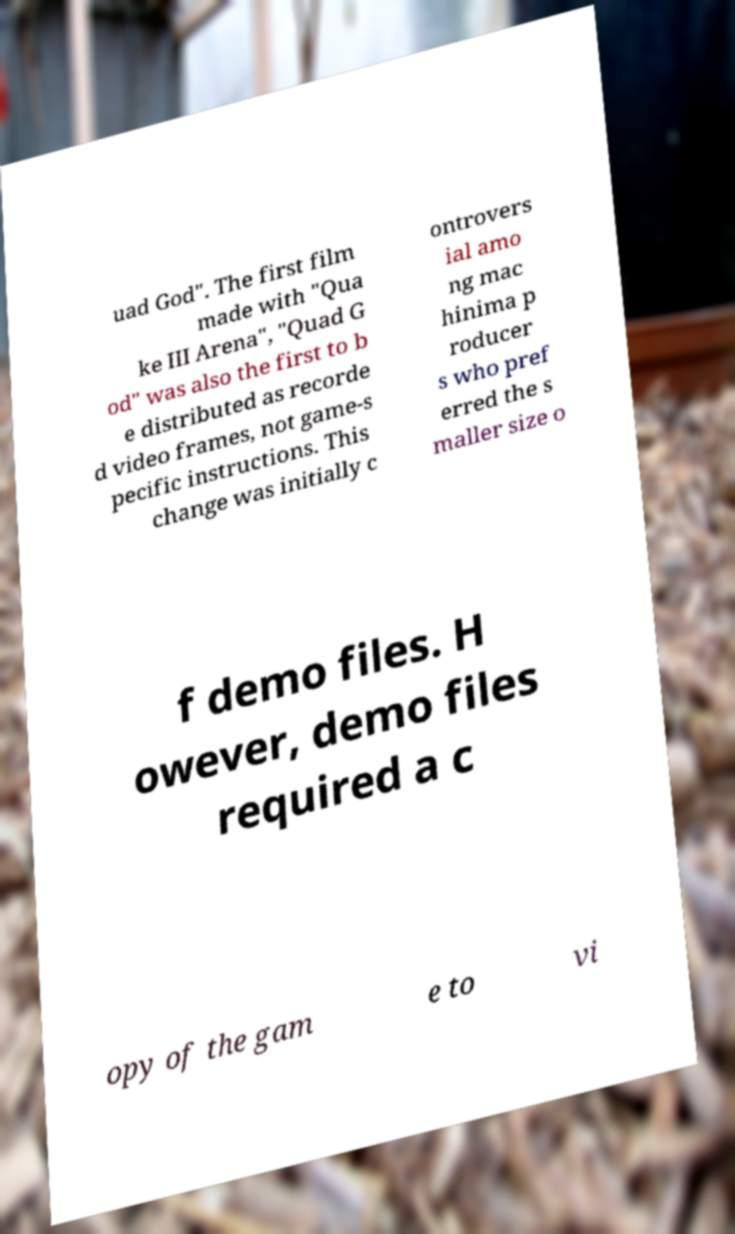Could you extract and type out the text from this image? uad God". The first film made with "Qua ke III Arena", "Quad G od" was also the first to b e distributed as recorde d video frames, not game-s pecific instructions. This change was initially c ontrovers ial amo ng mac hinima p roducer s who pref erred the s maller size o f demo files. H owever, demo files required a c opy of the gam e to vi 